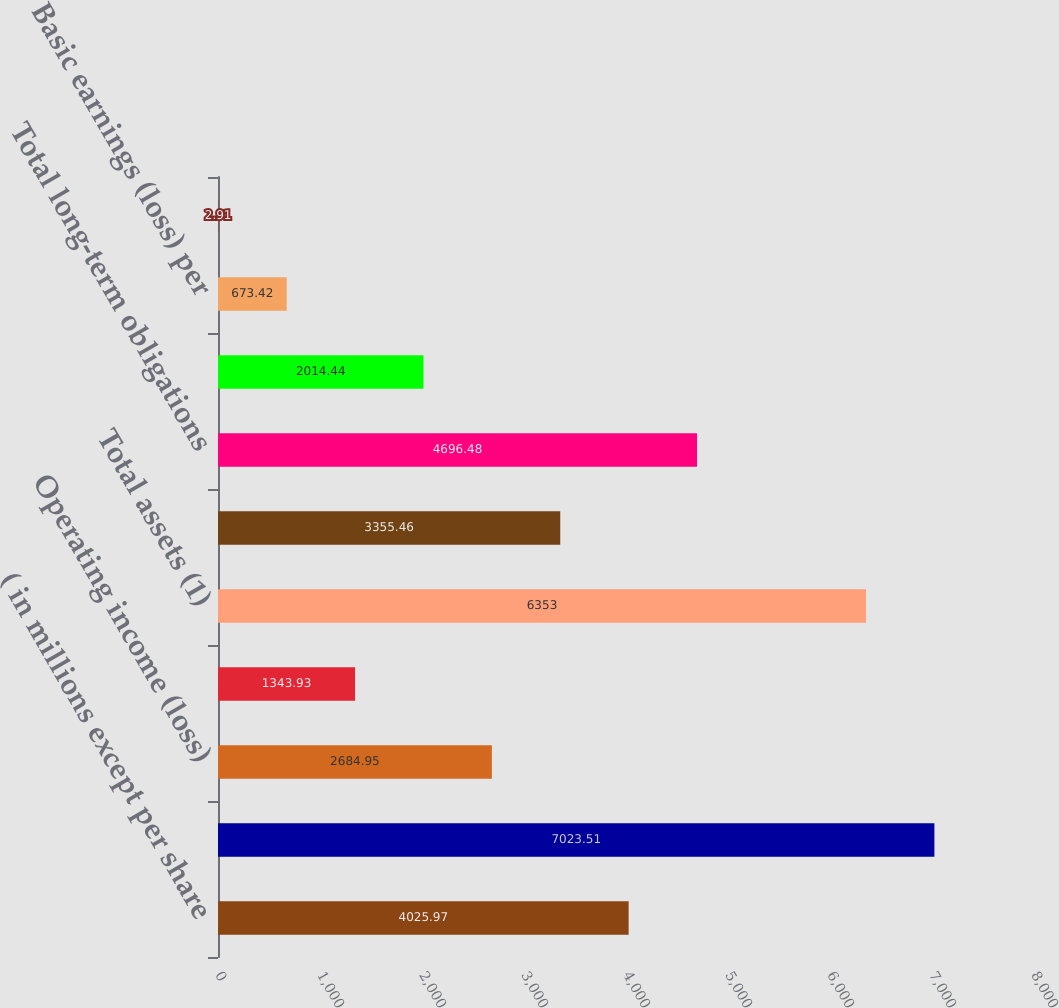<chart> <loc_0><loc_0><loc_500><loc_500><bar_chart><fcel>( in millions except per share<fcel>Sales and service revenues<fcel>Operating income (loss)<fcel>Net earnings (loss)<fcel>Total assets (1)<fcel>Long-term debt (1)(2)<fcel>Total long-term obligations<fcel>Free cash flow (3)<fcel>Basic earnings (loss) per<fcel>Diluted earnings (loss) per<nl><fcel>4025.97<fcel>7023.51<fcel>2684.95<fcel>1343.93<fcel>6353<fcel>3355.46<fcel>4696.48<fcel>2014.44<fcel>673.42<fcel>2.91<nl></chart> 